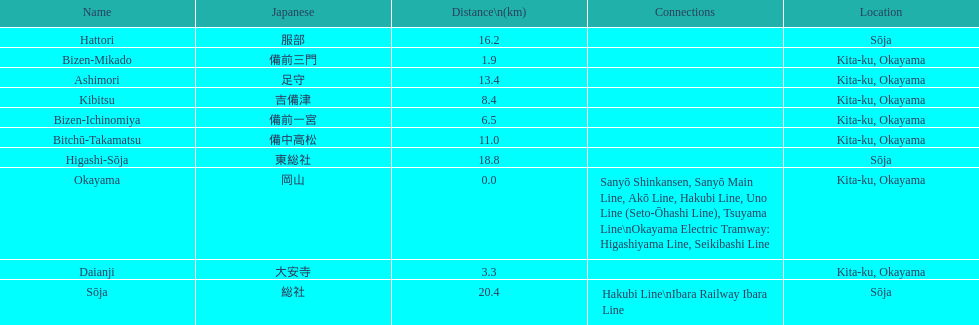Which has the most distance, hattori or kibitsu? Hattori. 